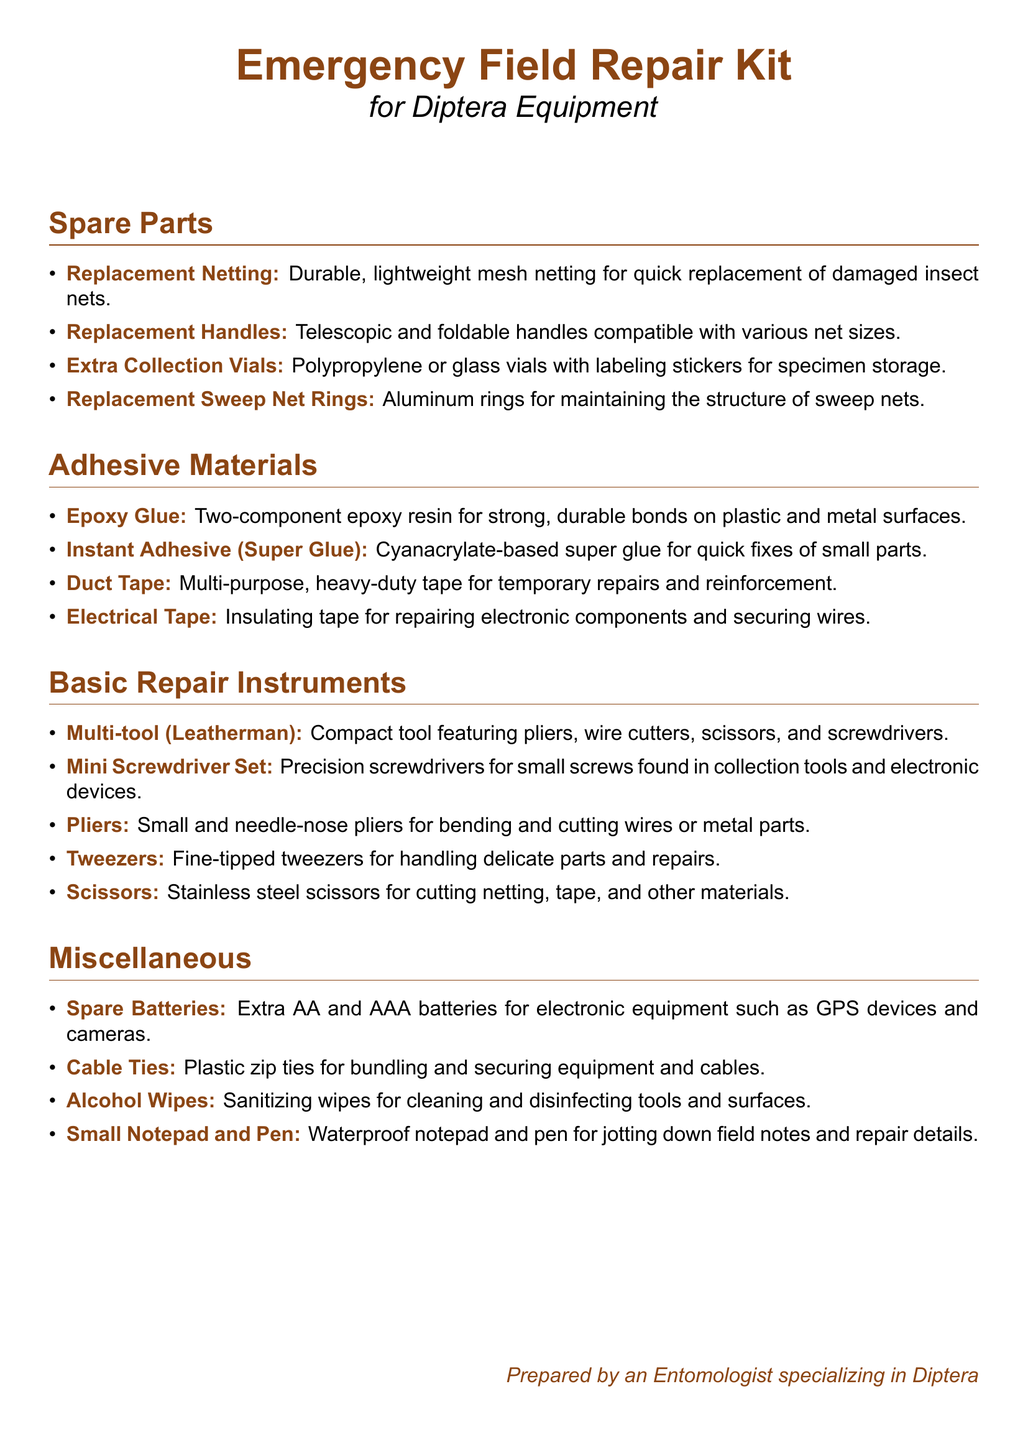What is the primary purpose of this document? The primary purpose of the document is to outline the contents of an emergency field repair kit for Diptera equipment.
Answer: Emergency Field Repair Kit How many sections are in the document? The document has four main sections: Spare Parts, Adhesive Materials, Basic Repair Instruments, and Miscellaneous.
Answer: Four What type of adhesive is used for quick fixes of small parts? The document specifies super glue as the adhesive for quick fixes.
Answer: Instant Adhesive (Super Glue) What item is listed for handling delicate parts? The document mentions tweezers as the suitable item for handling delicate parts.
Answer: Tweezers What is the color of the main title used in the document? The color of the main title is a specific shade identified in the document.
Answer: Dipterabrown Which spare part is needed for maintaining sweep nets? The document lists replacement sweep net rings for maintaining the structure of sweep nets.
Answer: Replacement Sweep Net Rings What type of tool is suggested for general repairs? The document suggests using a multi-tool for general repairs in the field.
Answer: Multi-tool (Leatherman) What is a miscellaneous item included for sanitization? The document includes alcohol wipes as a miscellaneous item for cleaning and disinfecting tools.
Answer: Alcohol Wipes How many types of batteries are mentioned in the miscellaneous section? The document specifies two types of batteries: AA and AAA.
Answer: Two 